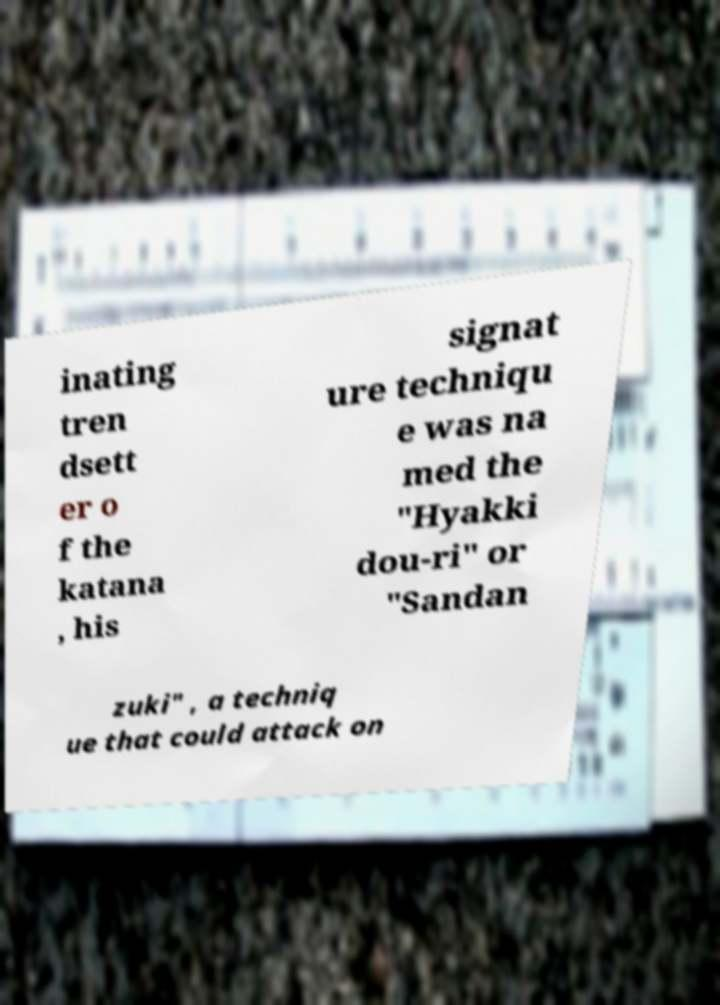Please read and relay the text visible in this image. What does it say? inating tren dsett er o f the katana , his signat ure techniqu e was na med the "Hyakki dou-ri" or "Sandan zuki" , a techniq ue that could attack on 